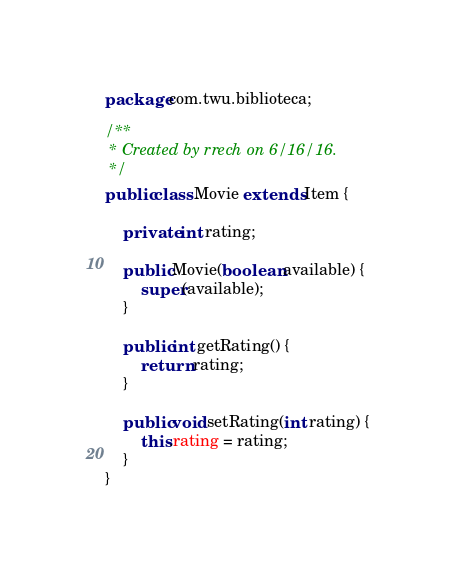<code> <loc_0><loc_0><loc_500><loc_500><_Java_>package com.twu.biblioteca;

/**
 * Created by rrech on 6/16/16.
 */
public class Movie extends Item {

    private int rating;

    public Movie(boolean available) {
        super(available);
    }

    public int getRating() {
        return rating;
    }

    public void setRating(int rating) {
        this.rating = rating;
    }
}
</code> 